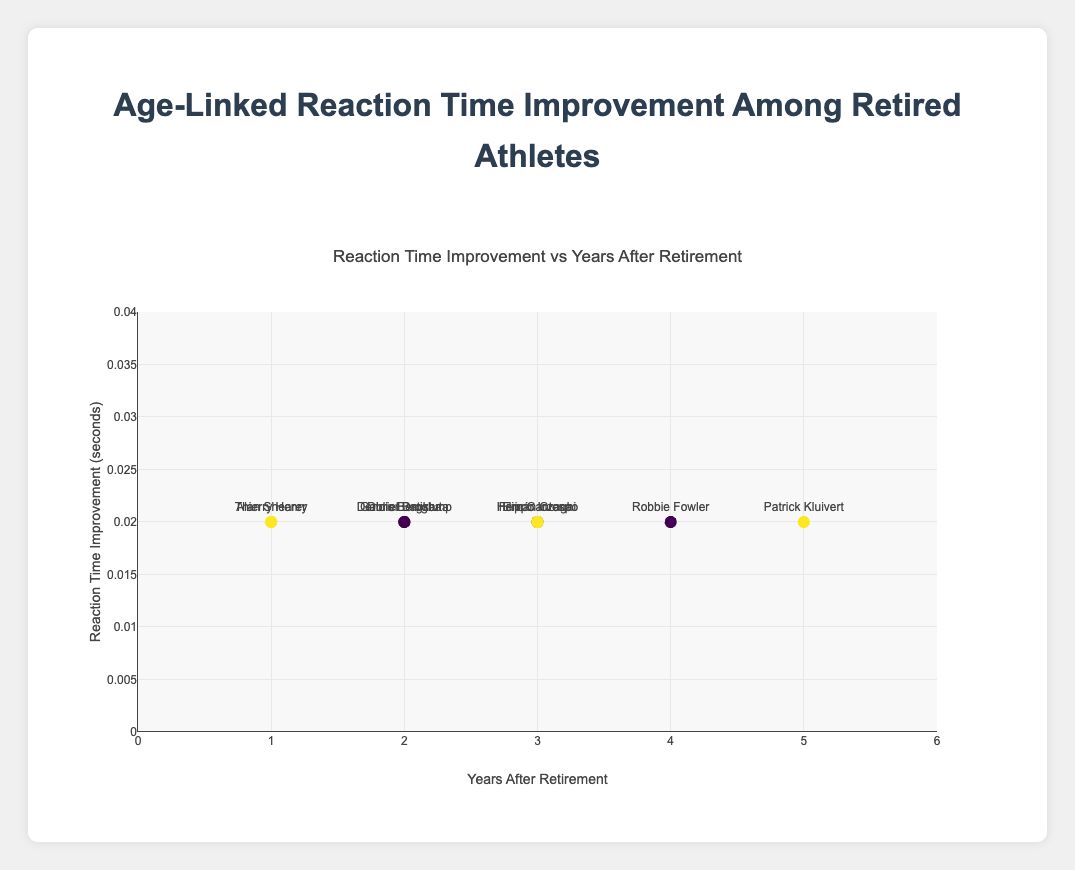What is the title of the figure? The title is displayed at the top of the plot area. It states the main focus of the figure.
Answer: Age-Linked Reaction Time Improvement Among Retired Athletes How many data points are plotted in the figure? The total count of markers on the plot corresponds to the number of data points.
Answer: 10 Which athlete shows the highest improvement in reaction time? By inspecting all the y-values, the highest improvement is indicated by the max y-value, and the corresponding athlete name.
Answer: Didier Drogba What is the range of the x-axis? The x-axis range can be observed by looking at the minimum and maximum values along the x-axis.
Answer: 0 to 6 How does reaction time improvement generally correlate with years after retirement? By observing the trend line, which indicates the overall direction of the data. A positive slope implies improvement increases with years, while a negative slope implies the opposite.
Answer: Positive correlation Which athlete shows the least improvement in reaction time? By inspecting all the y-values, the least improvement is indicated by the min y-value, and the corresponding athlete name.
Answer: Patrick Kluivert What is the color of the trend line? The trend line's color is clearly visible and distinct from the data points.
Answer: Red Who had the highest initial reaction time and how much did they improve post-retirement? Identify the highest initial reaction time from the data points, then refer to the corresponding y-value improvement and athlete name. The data point's hover information assists in this.
Answer: Patrick Kluivert, 0.02 seconds What are the lowest and highest values on the y-axis? The y-axis range can be seen by the minimum and maximum values marked on the axis.
Answer: 0 to 0.04 How much did Alan Shearer’s reaction time improve post-retirement? To find this, locate Alan Shearer on the plot and read the y-value associated with his marker.
Answer: 0.02 seconds 